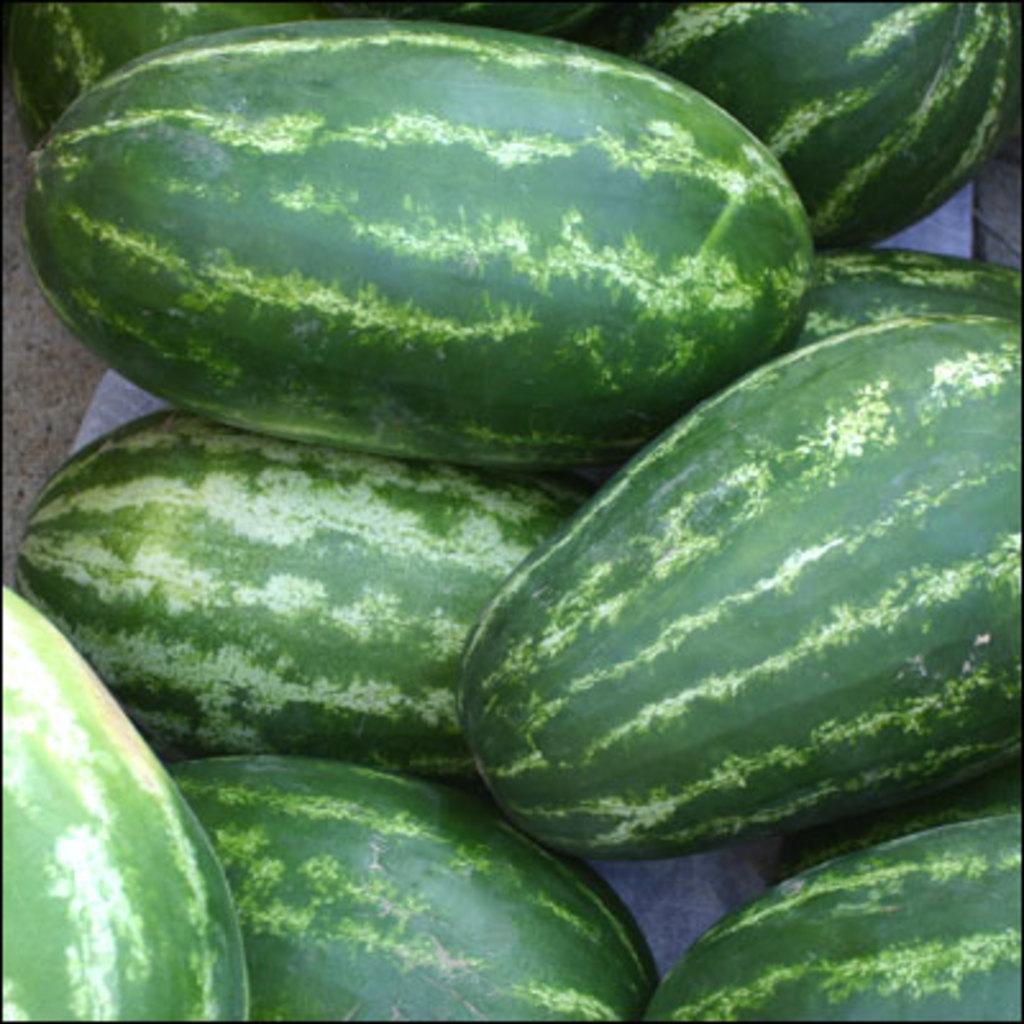Can you describe this image briefly? This picture consists of watermelons in the image. 